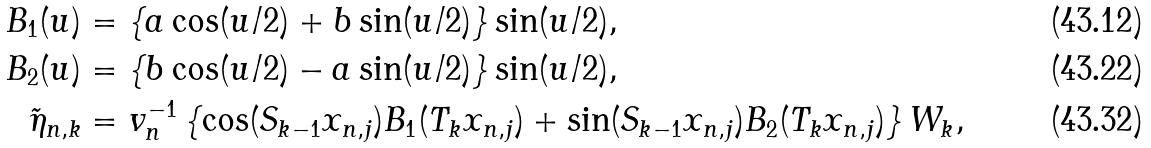<formula> <loc_0><loc_0><loc_500><loc_500>B _ { 1 } ( u ) & = \{ a \cos ( u / 2 ) + b \sin ( u / 2 ) \} \sin ( u / 2 ) , \\ B _ { 2 } ( u ) & = \{ b \cos ( u / 2 ) - a \sin ( u / 2 ) \} \sin ( u / 2 ) , \\ \tilde { \eta } _ { n , k } & = v _ { n } ^ { - 1 } \left \{ \cos ( S _ { k - 1 } x _ { n , j } ) B _ { 1 } ( T _ { k } x _ { n , j } ) + \sin ( S _ { k - 1 } x _ { n , j } ) B _ { 2 } ( T _ { k } x _ { n , j } ) \right \} W _ { k } ,</formula> 